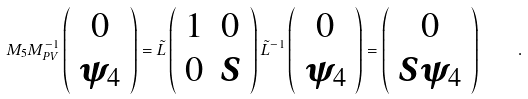<formula> <loc_0><loc_0><loc_500><loc_500>M _ { 5 } M ^ { - 1 } _ { P V } \left ( \begin{array} { c } { 0 } \\ { \psi _ { 4 } } \end{array} \right ) = { \tilde { L } } \left ( \begin{array} { c c } { 1 } & 0 \\ 0 & { S } \end{array} \right ) { \tilde { L } ^ { - 1 } } \left ( \begin{array} { c } { 0 } \\ { \psi _ { 4 } } \end{array} \right ) = \left ( \begin{array} { c } { 0 } \\ { S \psi _ { 4 } } \end{array} \right ) \quad .</formula> 